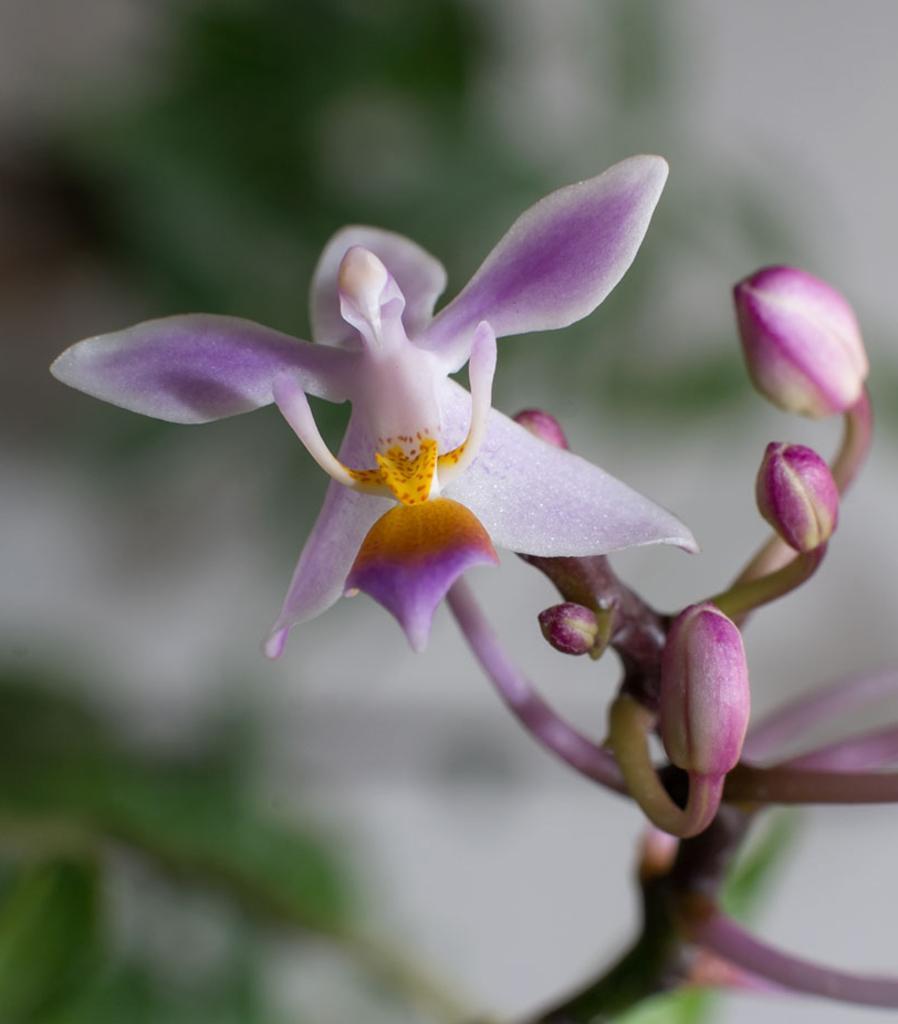Describe this image in one or two sentences. In this image there is a plant stem towards the bottom of the image, there is a flower, there are buds, the background of the image is blurred. 